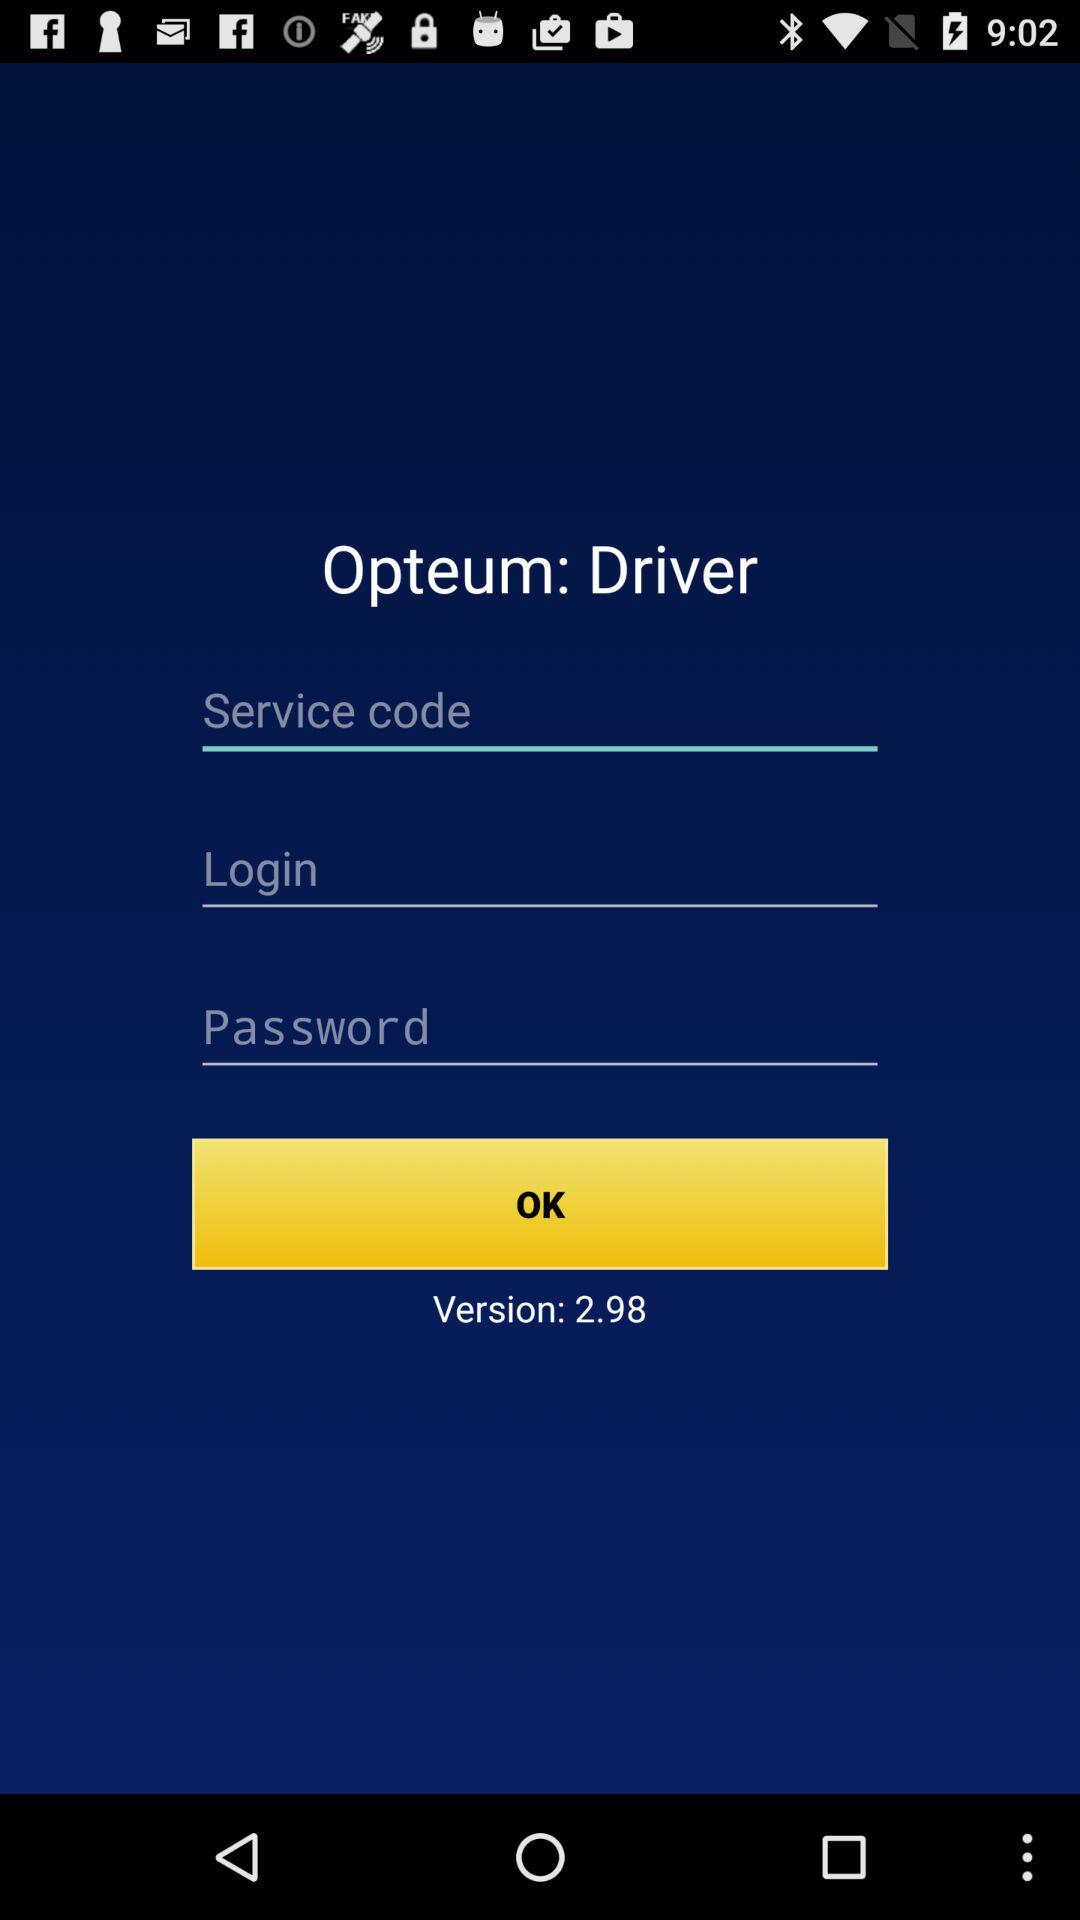What is the name of the application? The name of the application is "Opteum: Driver". 